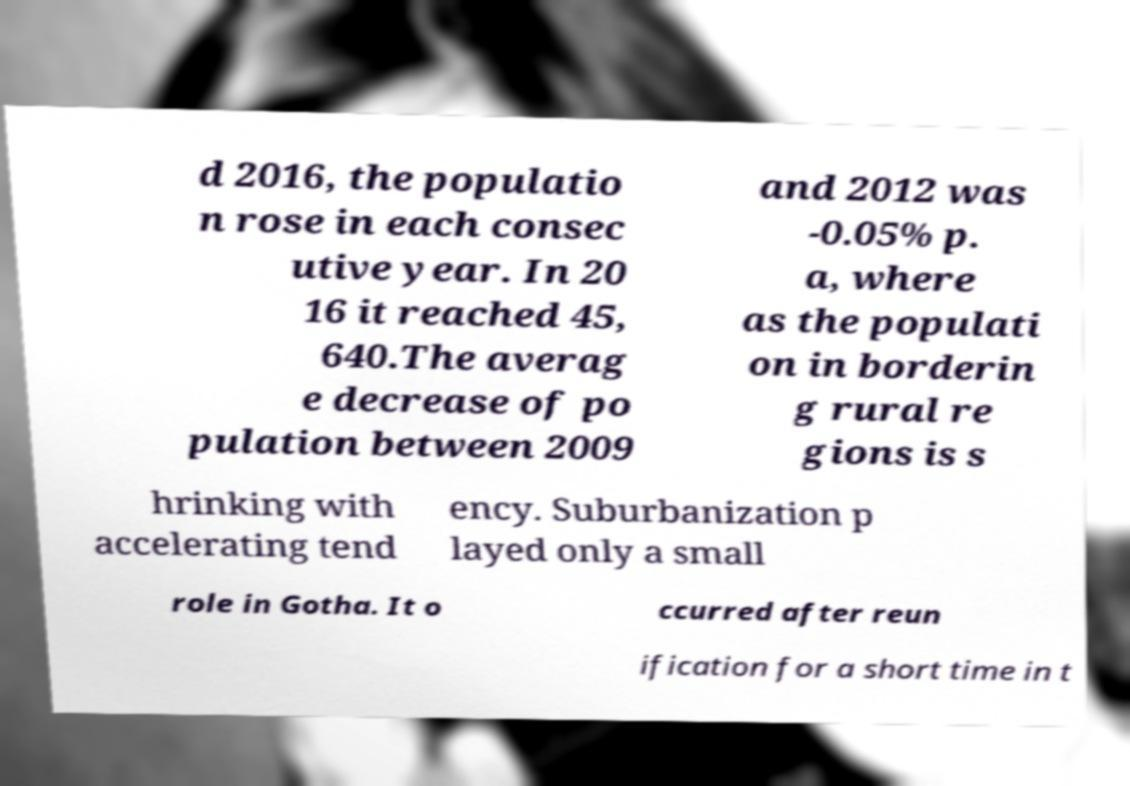Please identify and transcribe the text found in this image. d 2016, the populatio n rose in each consec utive year. In 20 16 it reached 45, 640.The averag e decrease of po pulation between 2009 and 2012 was -0.05% p. a, where as the populati on in borderin g rural re gions is s hrinking with accelerating tend ency. Suburbanization p layed only a small role in Gotha. It o ccurred after reun ification for a short time in t 